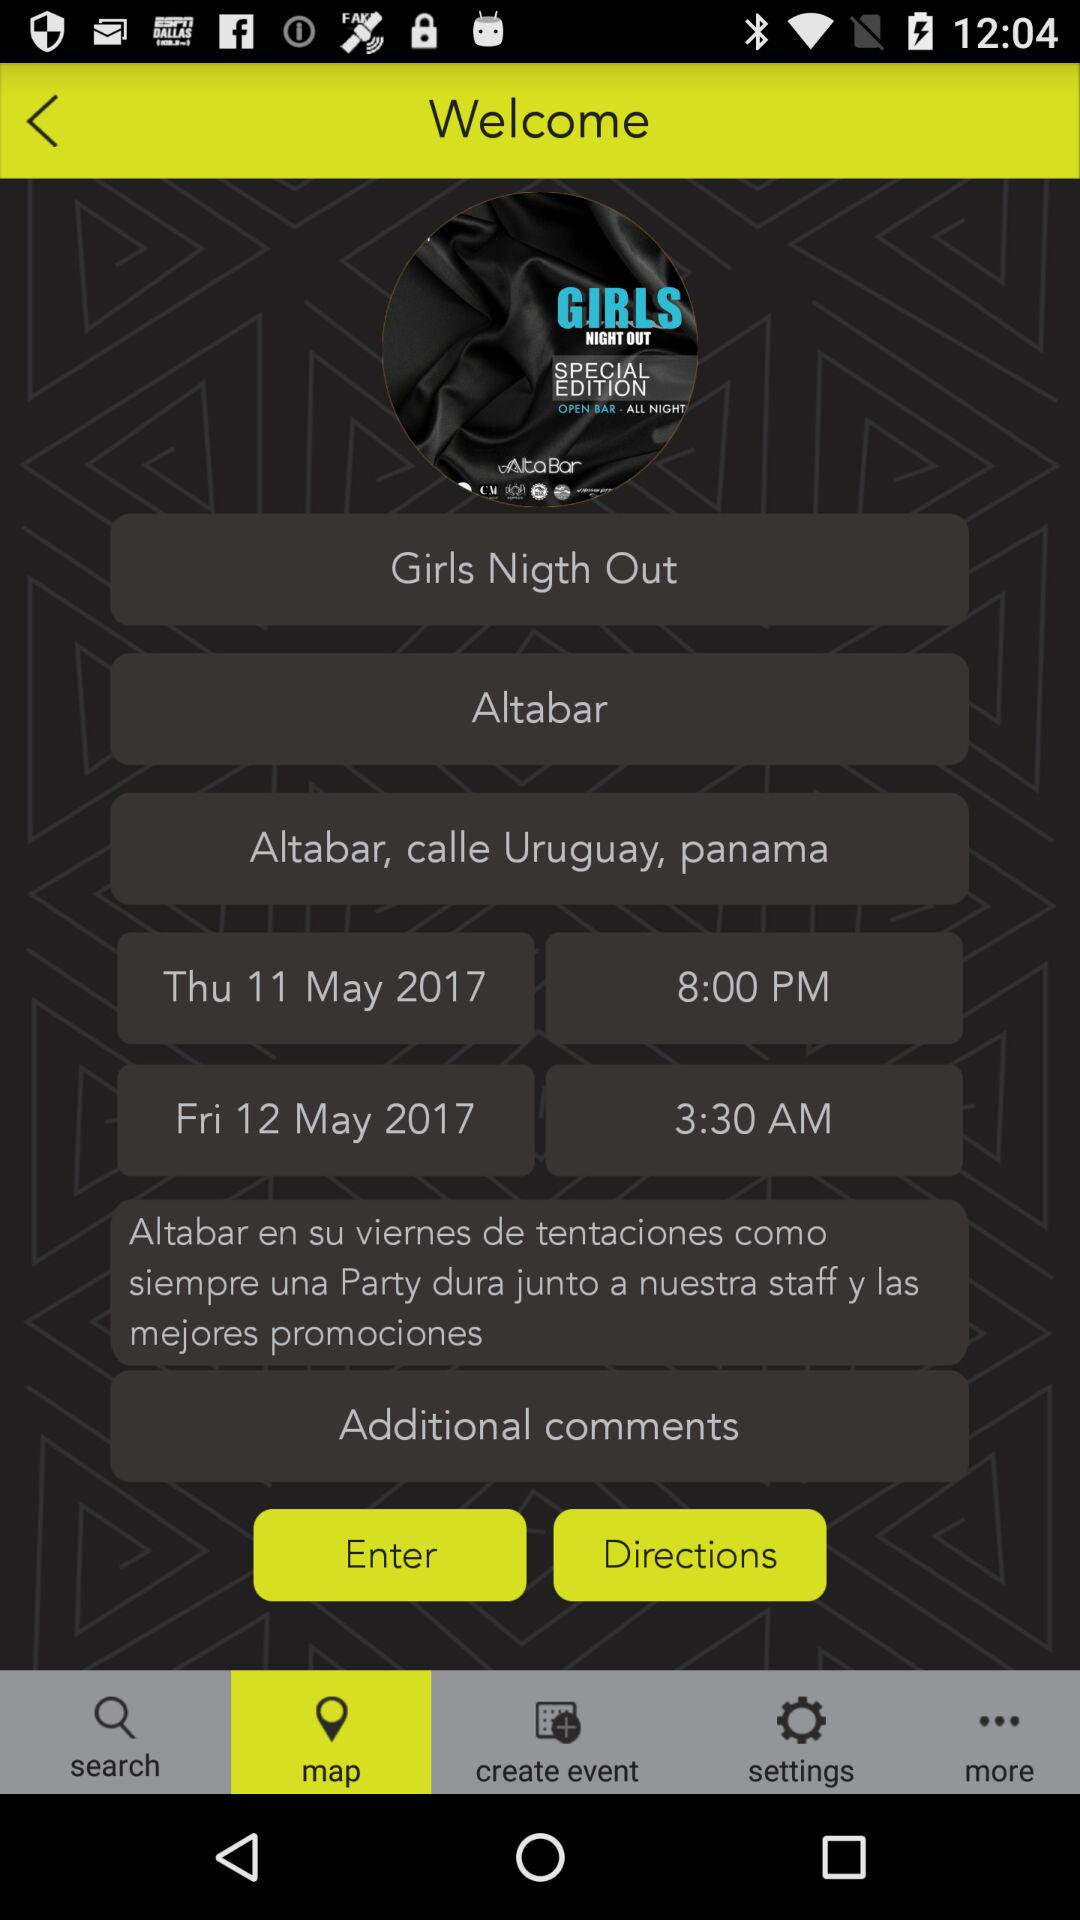What is the address? The address is "Altabar, calle Uruguay, panama". 